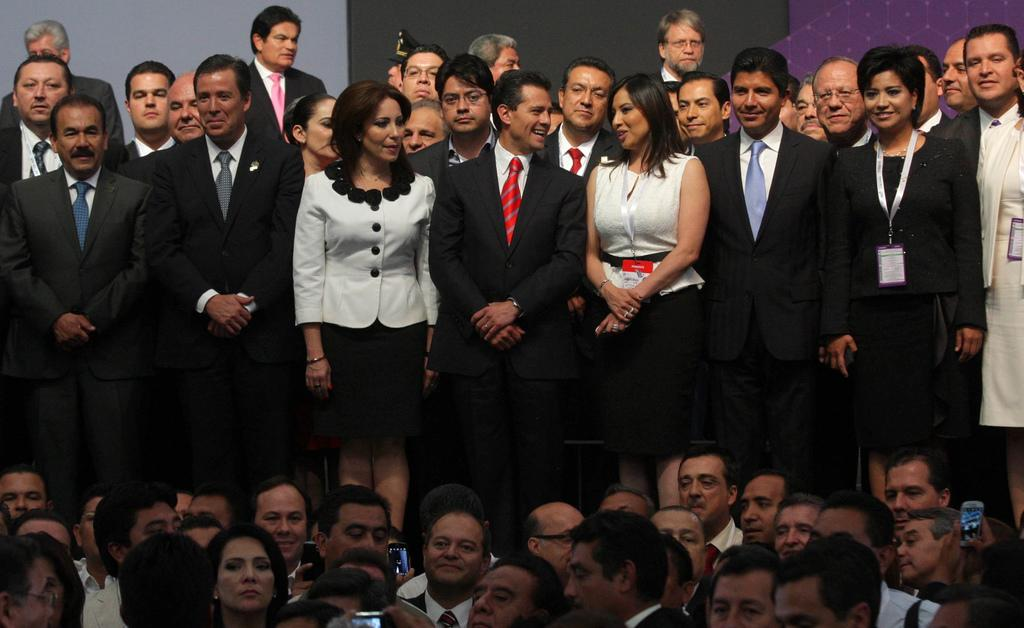What is happening in the image involving a group of people? There is a group of people standing in the image. What can be seen in the background of the image? There appears to be a board in the background of the image. Can you describe the positioning of the people in the image? There are people at the bottom of the image. What objects are some people holding in the image? Some people are holding cell phones in the image. What type of bait is being used by the beginner in the image? There is no fishing or bait present in the image; it features a group of people standing with some holding cell phones. 